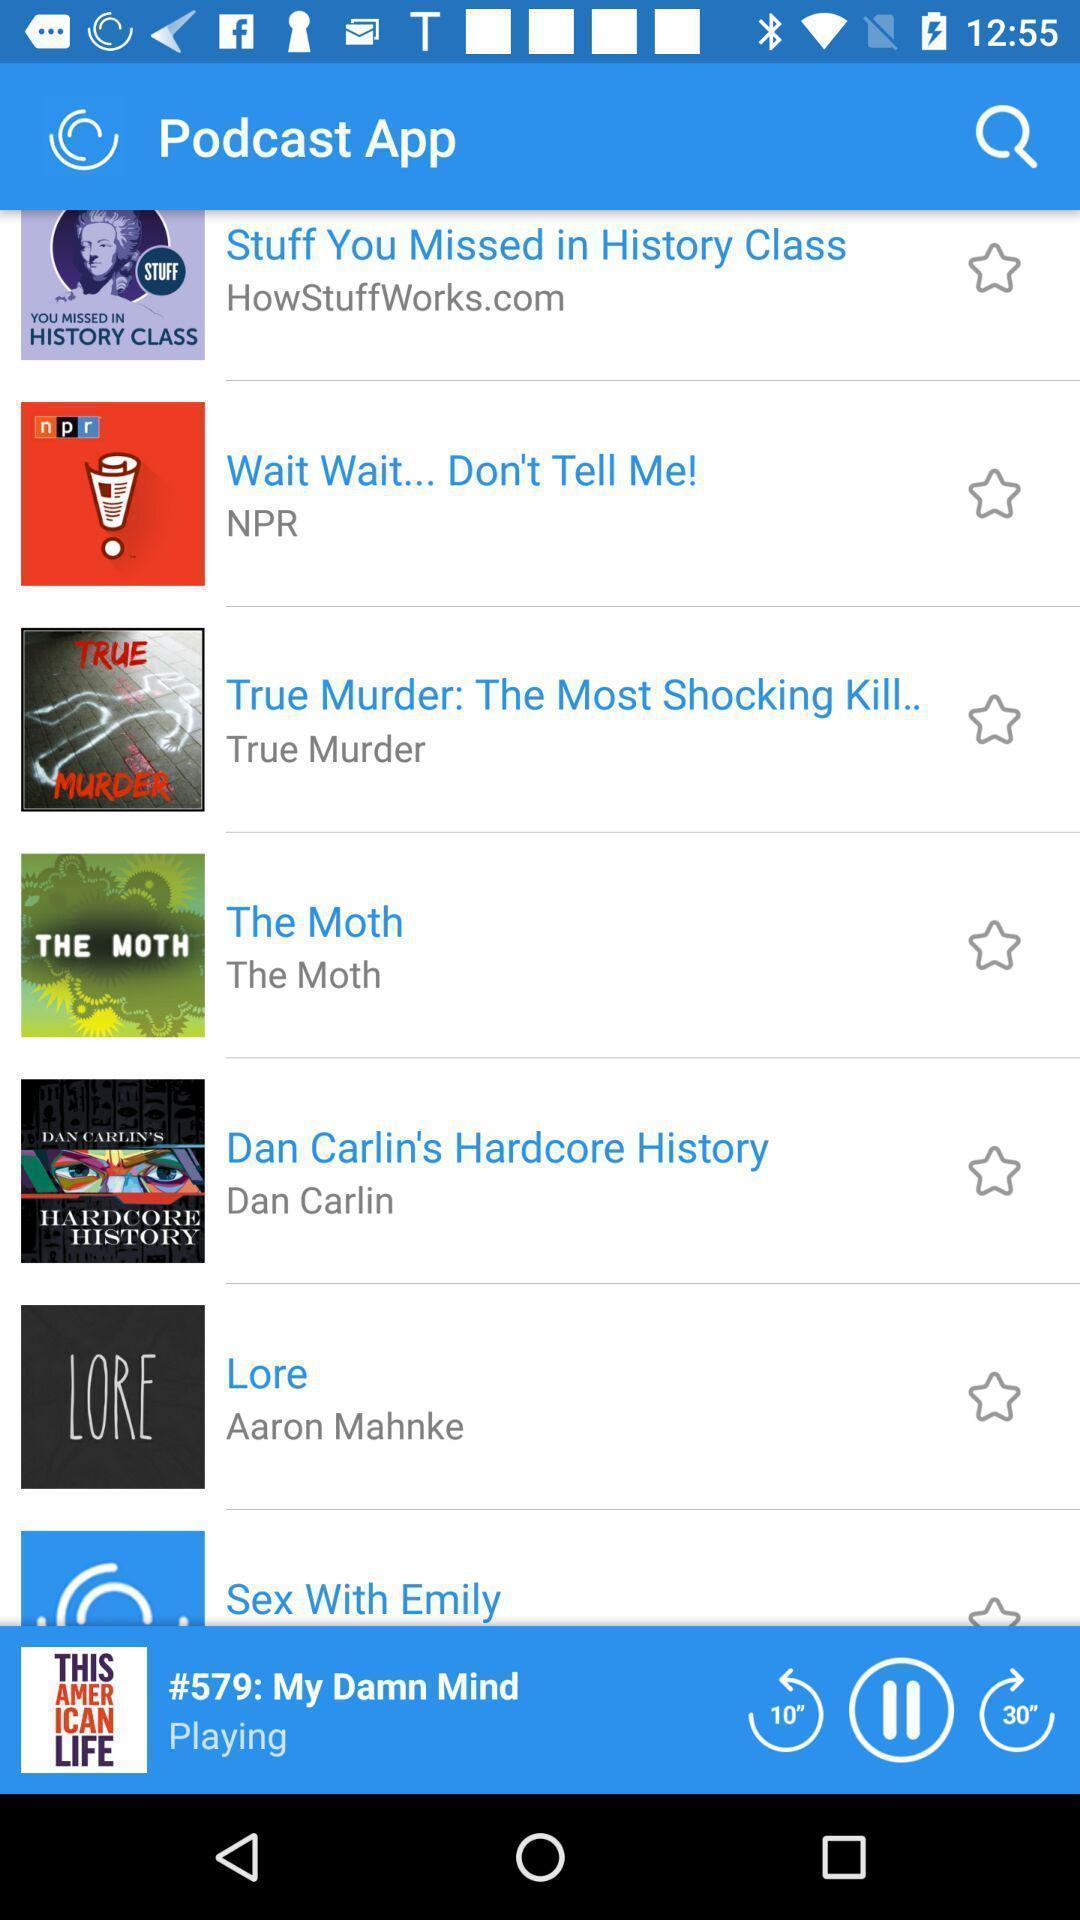Provide a detailed account of this screenshot. Screen shows about podcast app. 